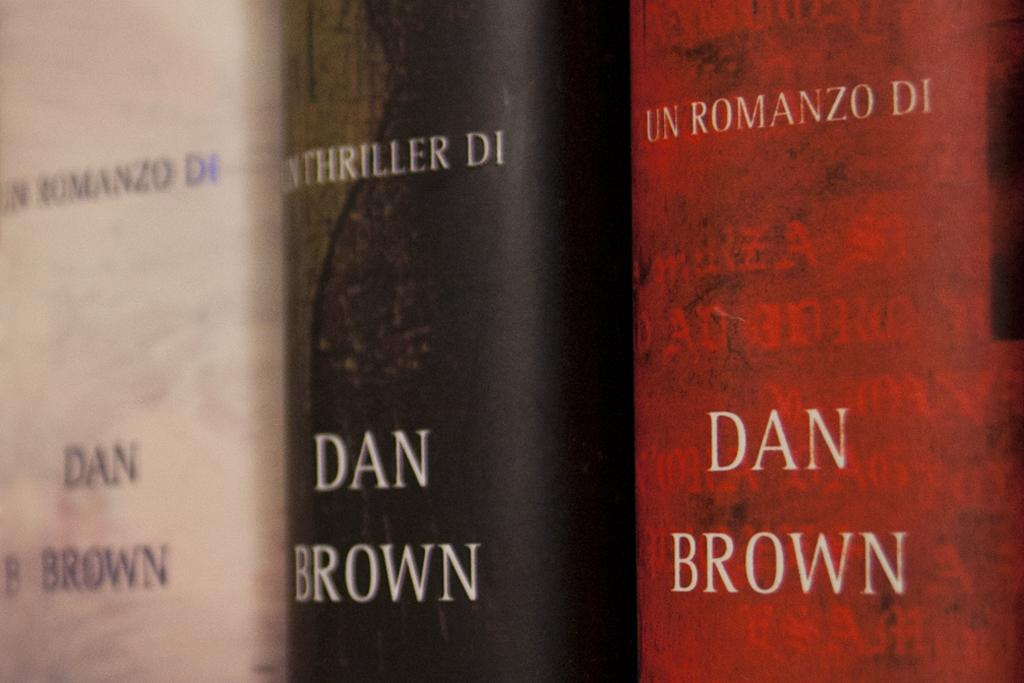<image>
Render a clear and concise summary of the photo. Three books by Dan Brown are next to each other. 